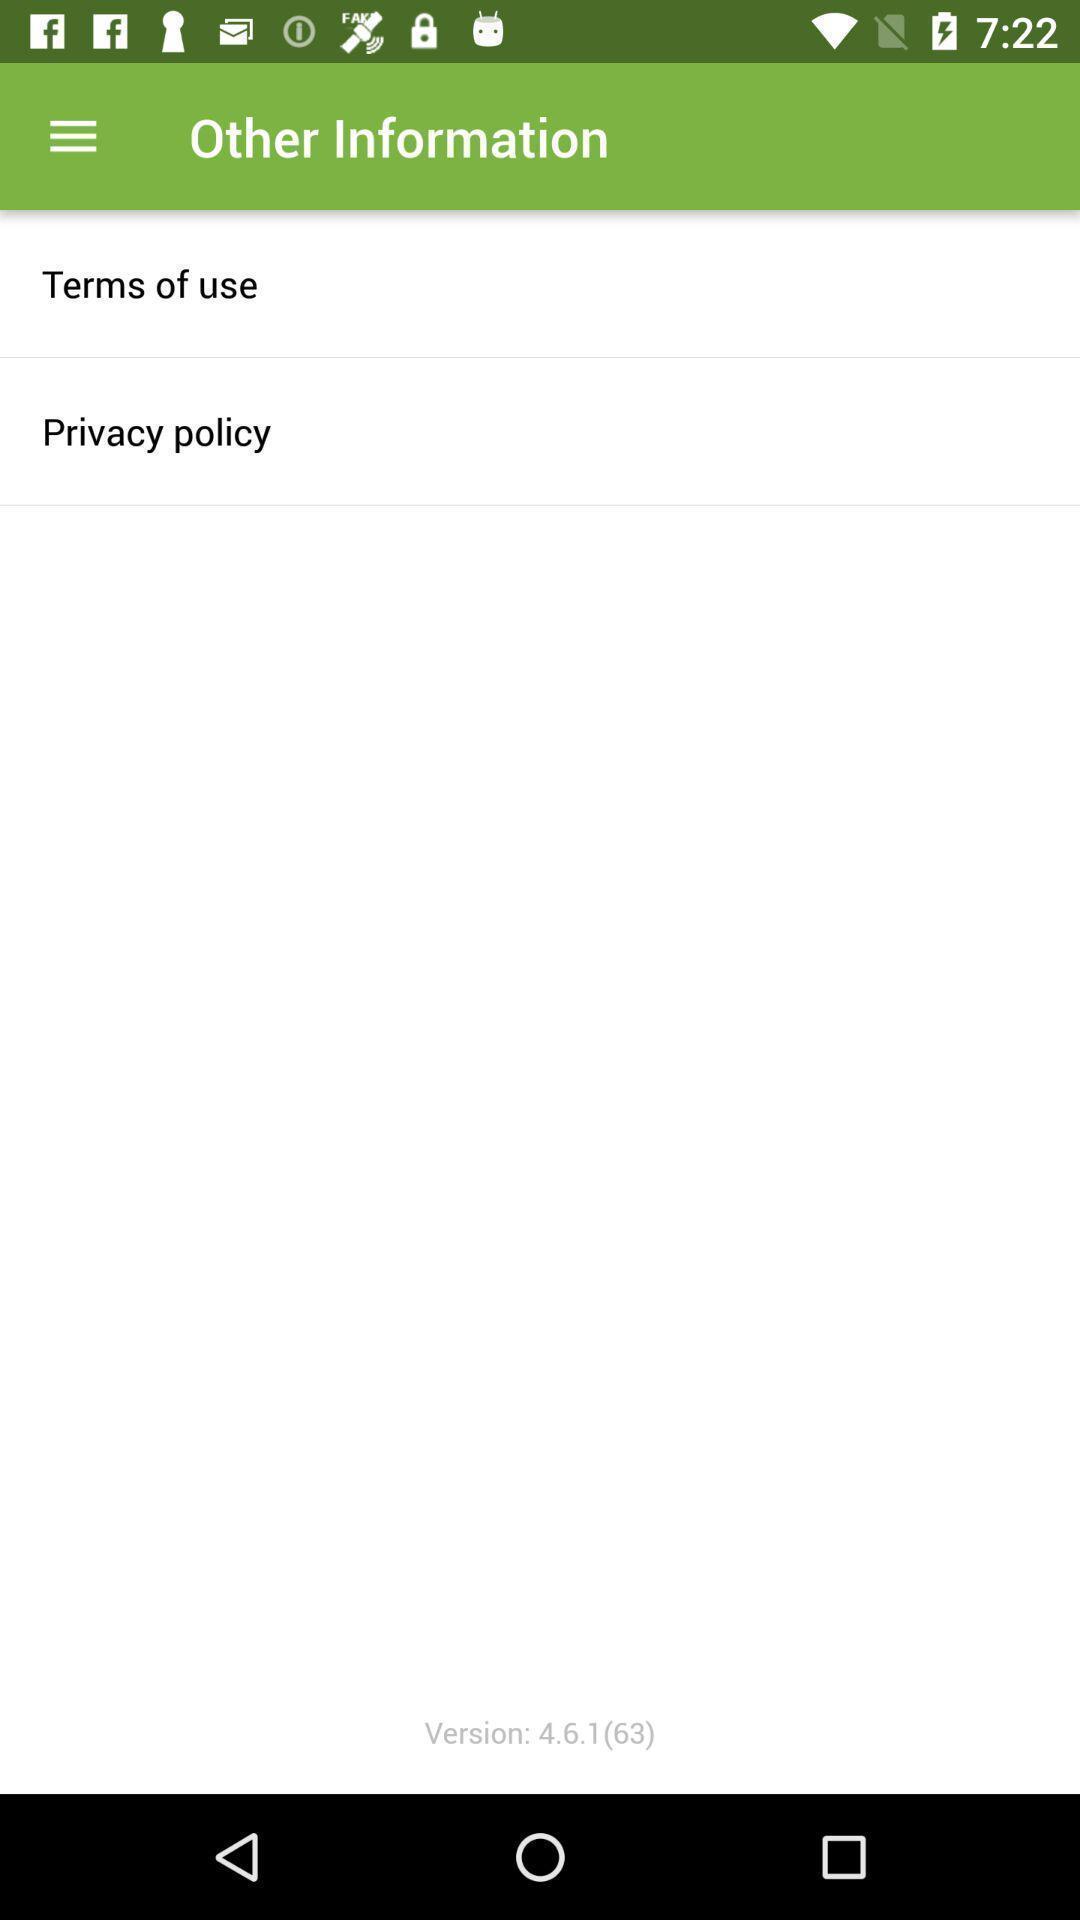What details can you identify in this image? Page displaying the other informations. 